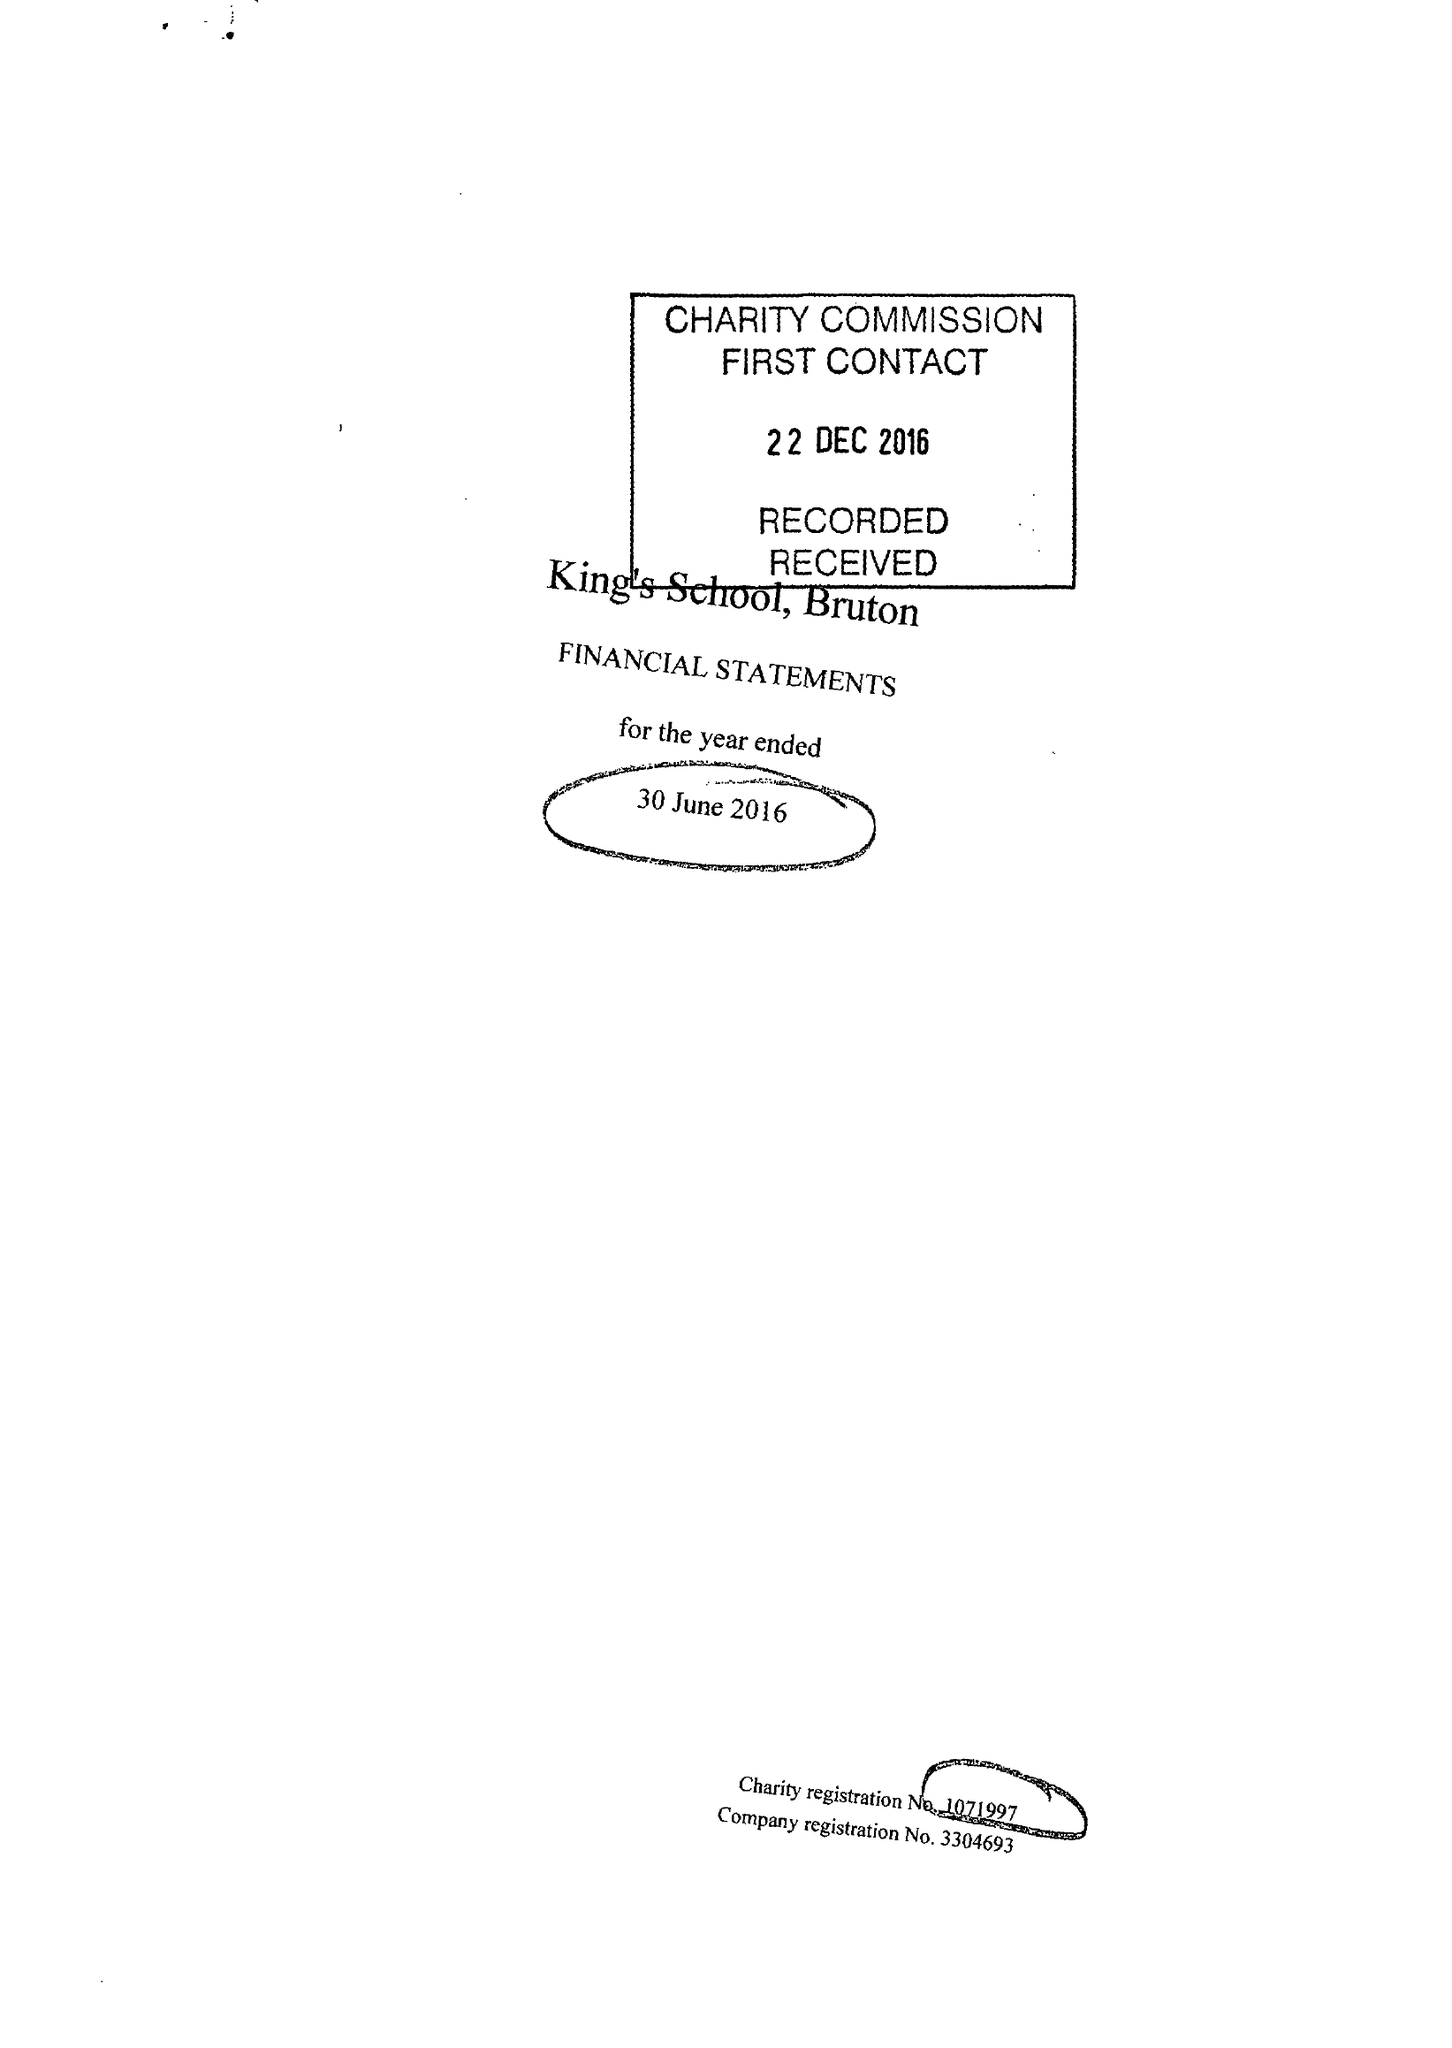What is the value for the address__street_line?
Answer the question using a single word or phrase. PLOX 